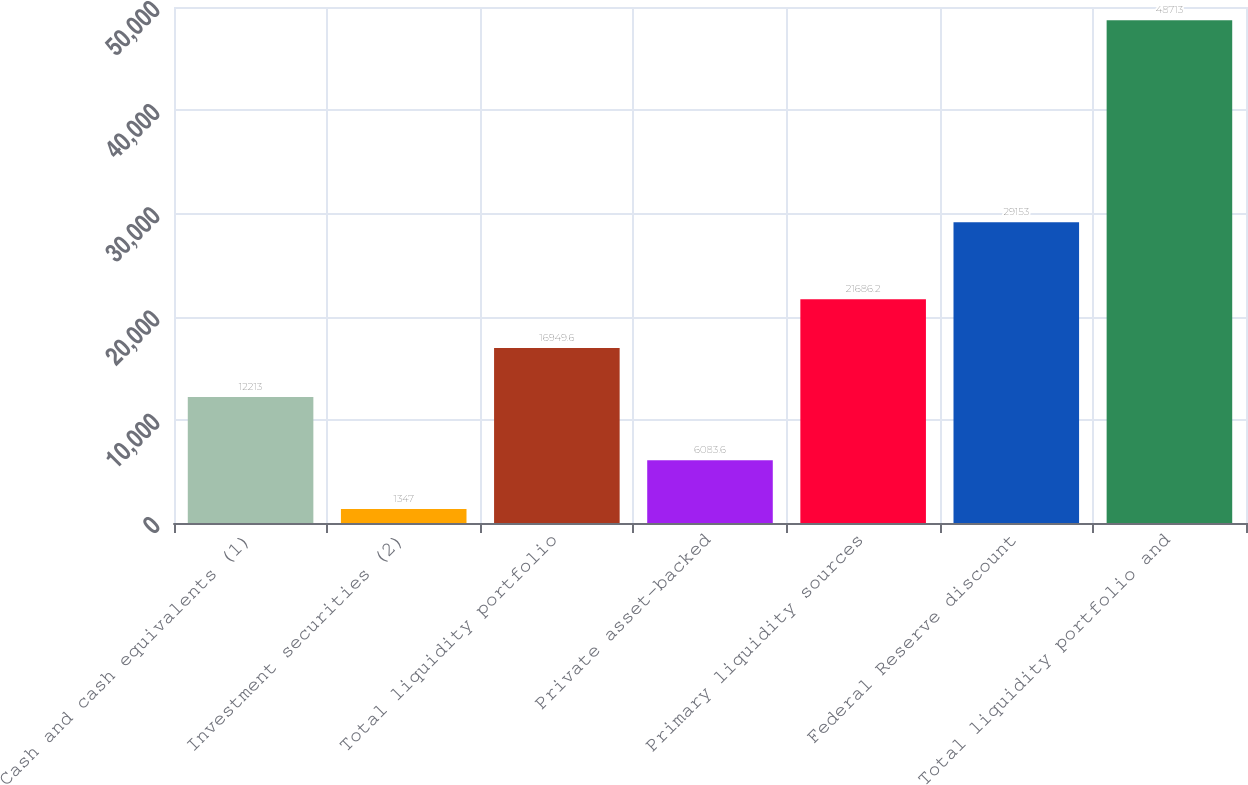<chart> <loc_0><loc_0><loc_500><loc_500><bar_chart><fcel>Cash and cash equivalents (1)<fcel>Investment securities (2)<fcel>Total liquidity portfolio<fcel>Private asset-backed<fcel>Primary liquidity sources<fcel>Federal Reserve discount<fcel>Total liquidity portfolio and<nl><fcel>12213<fcel>1347<fcel>16949.6<fcel>6083.6<fcel>21686.2<fcel>29153<fcel>48713<nl></chart> 